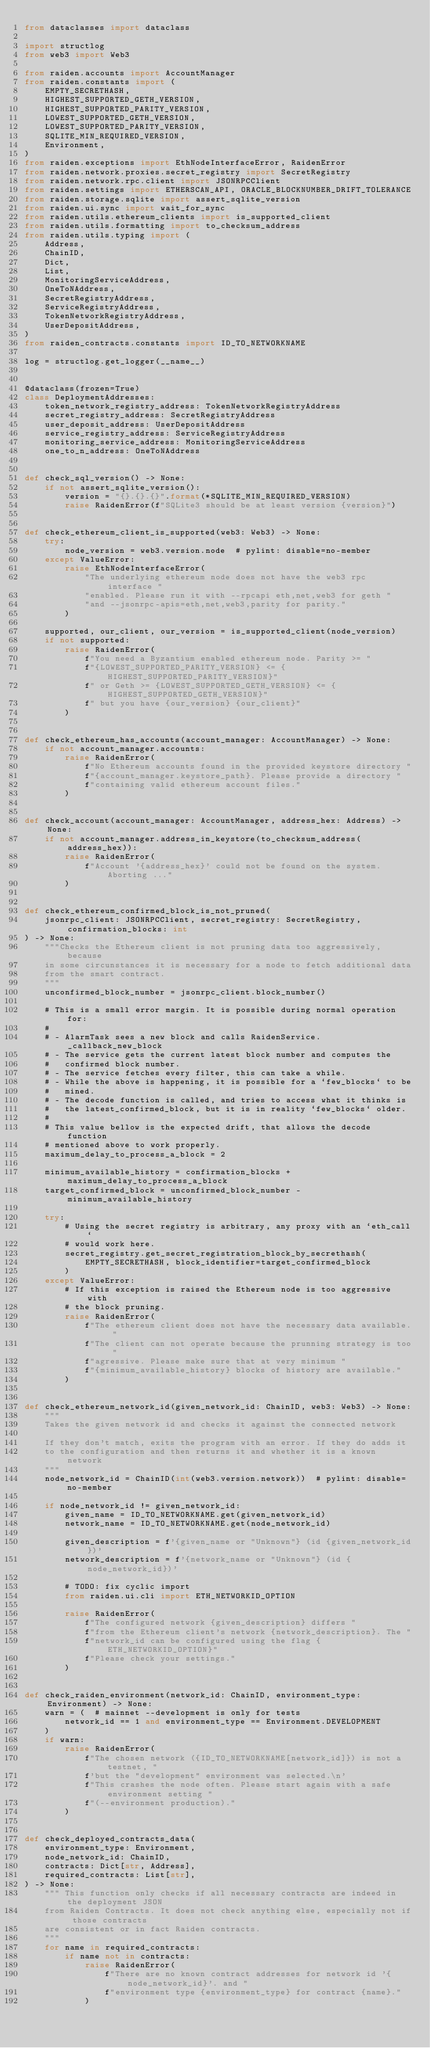Convert code to text. <code><loc_0><loc_0><loc_500><loc_500><_Python_>from dataclasses import dataclass

import structlog
from web3 import Web3

from raiden.accounts import AccountManager
from raiden.constants import (
    EMPTY_SECRETHASH,
    HIGHEST_SUPPORTED_GETH_VERSION,
    HIGHEST_SUPPORTED_PARITY_VERSION,
    LOWEST_SUPPORTED_GETH_VERSION,
    LOWEST_SUPPORTED_PARITY_VERSION,
    SQLITE_MIN_REQUIRED_VERSION,
    Environment,
)
from raiden.exceptions import EthNodeInterfaceError, RaidenError
from raiden.network.proxies.secret_registry import SecretRegistry
from raiden.network.rpc.client import JSONRPCClient
from raiden.settings import ETHERSCAN_API, ORACLE_BLOCKNUMBER_DRIFT_TOLERANCE
from raiden.storage.sqlite import assert_sqlite_version
from raiden.ui.sync import wait_for_sync
from raiden.utils.ethereum_clients import is_supported_client
from raiden.utils.formatting import to_checksum_address
from raiden.utils.typing import (
    Address,
    ChainID,
    Dict,
    List,
    MonitoringServiceAddress,
    OneToNAddress,
    SecretRegistryAddress,
    ServiceRegistryAddress,
    TokenNetworkRegistryAddress,
    UserDepositAddress,
)
from raiden_contracts.constants import ID_TO_NETWORKNAME

log = structlog.get_logger(__name__)


@dataclass(frozen=True)
class DeploymentAddresses:
    token_network_registry_address: TokenNetworkRegistryAddress
    secret_registry_address: SecretRegistryAddress
    user_deposit_address: UserDepositAddress
    service_registry_address: ServiceRegistryAddress
    monitoring_service_address: MonitoringServiceAddress
    one_to_n_address: OneToNAddress


def check_sql_version() -> None:
    if not assert_sqlite_version():
        version = "{}.{}.{}".format(*SQLITE_MIN_REQUIRED_VERSION)
        raise RaidenError(f"SQLite3 should be at least version {version}")


def check_ethereum_client_is_supported(web3: Web3) -> None:
    try:
        node_version = web3.version.node  # pylint: disable=no-member
    except ValueError:
        raise EthNodeInterfaceError(
            "The underlying ethereum node does not have the web3 rpc interface "
            "enabled. Please run it with --rpcapi eth,net,web3 for geth "
            "and --jsonrpc-apis=eth,net,web3,parity for parity."
        )

    supported, our_client, our_version = is_supported_client(node_version)
    if not supported:
        raise RaidenError(
            f"You need a Byzantium enabled ethereum node. Parity >= "
            f"{LOWEST_SUPPORTED_PARITY_VERSION} <= {HIGHEST_SUPPORTED_PARITY_VERSION}"
            f" or Geth >= {LOWEST_SUPPORTED_GETH_VERSION} <= {HIGHEST_SUPPORTED_GETH_VERSION}"
            f" but you have {our_version} {our_client}"
        )


def check_ethereum_has_accounts(account_manager: AccountManager) -> None:
    if not account_manager.accounts:
        raise RaidenError(
            f"No Ethereum accounts found in the provided keystore directory "
            f"{account_manager.keystore_path}. Please provide a directory "
            f"containing valid ethereum account files."
        )


def check_account(account_manager: AccountManager, address_hex: Address) -> None:
    if not account_manager.address_in_keystore(to_checksum_address(address_hex)):
        raise RaidenError(
            f"Account '{address_hex}' could not be found on the system. Aborting ..."
        )


def check_ethereum_confirmed_block_is_not_pruned(
    jsonrpc_client: JSONRPCClient, secret_registry: SecretRegistry, confirmation_blocks: int
) -> None:
    """Checks the Ethereum client is not pruning data too aggressively, because
    in some circunstances it is necessary for a node to fetch additional data
    from the smart contract.
    """
    unconfirmed_block_number = jsonrpc_client.block_number()

    # This is a small error margin. It is possible during normal operation for:
    #
    # - AlarmTask sees a new block and calls RaidenService._callback_new_block
    # - The service gets the current latest block number and computes the
    #   confirmed block number.
    # - The service fetches every filter, this can take a while.
    # - While the above is happening, it is possible for a `few_blocks` to be
    #   mined.
    # - The decode function is called, and tries to access what it thinks is
    #   the latest_confirmed_block, but it is in reality `few_blocks` older.
    #
    # This value bellow is the expected drift, that allows the decode function
    # mentioned above to work properly.
    maximum_delay_to_process_a_block = 2

    minimum_available_history = confirmation_blocks + maximum_delay_to_process_a_block
    target_confirmed_block = unconfirmed_block_number - minimum_available_history

    try:
        # Using the secret registry is arbitrary, any proxy with an `eth_call`
        # would work here.
        secret_registry.get_secret_registration_block_by_secrethash(
            EMPTY_SECRETHASH, block_identifier=target_confirmed_block
        )
    except ValueError:
        # If this exception is raised the Ethereum node is too aggressive with
        # the block pruning.
        raise RaidenError(
            f"The ethereum client does not have the necessary data available. "
            f"The client can not operate because the prunning strategy is too "
            f"agressive. Please make sure that at very minimum "
            f"{minimum_available_history} blocks of history are available."
        )


def check_ethereum_network_id(given_network_id: ChainID, web3: Web3) -> None:
    """
    Takes the given network id and checks it against the connected network

    If they don't match, exits the program with an error. If they do adds it
    to the configuration and then returns it and whether it is a known network
    """
    node_network_id = ChainID(int(web3.version.network))  # pylint: disable=no-member

    if node_network_id != given_network_id:
        given_name = ID_TO_NETWORKNAME.get(given_network_id)
        network_name = ID_TO_NETWORKNAME.get(node_network_id)

        given_description = f'{given_name or "Unknown"} (id {given_network_id})'
        network_description = f'{network_name or "Unknown"} (id {node_network_id})'

        # TODO: fix cyclic import
        from raiden.ui.cli import ETH_NETWORKID_OPTION

        raise RaidenError(
            f"The configured network {given_description} differs "
            f"from the Ethereum client's network {network_description}. The "
            f"network_id can be configured using the flag {ETH_NETWORKID_OPTION}"
            f"Please check your settings."
        )


def check_raiden_environment(network_id: ChainID, environment_type: Environment) -> None:
    warn = (  # mainnet --development is only for tests
        network_id == 1 and environment_type == Environment.DEVELOPMENT
    )
    if warn:
        raise RaidenError(
            f"The chosen network ({ID_TO_NETWORKNAME[network_id]}) is not a testnet, "
            f'but the "development" environment was selected.\n'
            f"This crashes the node often. Please start again with a safe environment setting "
            f"(--environment production)."
        )


def check_deployed_contracts_data(
    environment_type: Environment,
    node_network_id: ChainID,
    contracts: Dict[str, Address],
    required_contracts: List[str],
) -> None:
    """ This function only checks if all necessary contracts are indeed in the deployment JSON
    from Raiden Contracts. It does not check anything else, especially not if those contracts
    are consistent or in fact Raiden contracts.
    """
    for name in required_contracts:
        if name not in contracts:
            raise RaidenError(
                f"There are no known contract addresses for network id '{node_network_id}'. and "
                f"environment type {environment_type} for contract {name}."
            )

</code> 